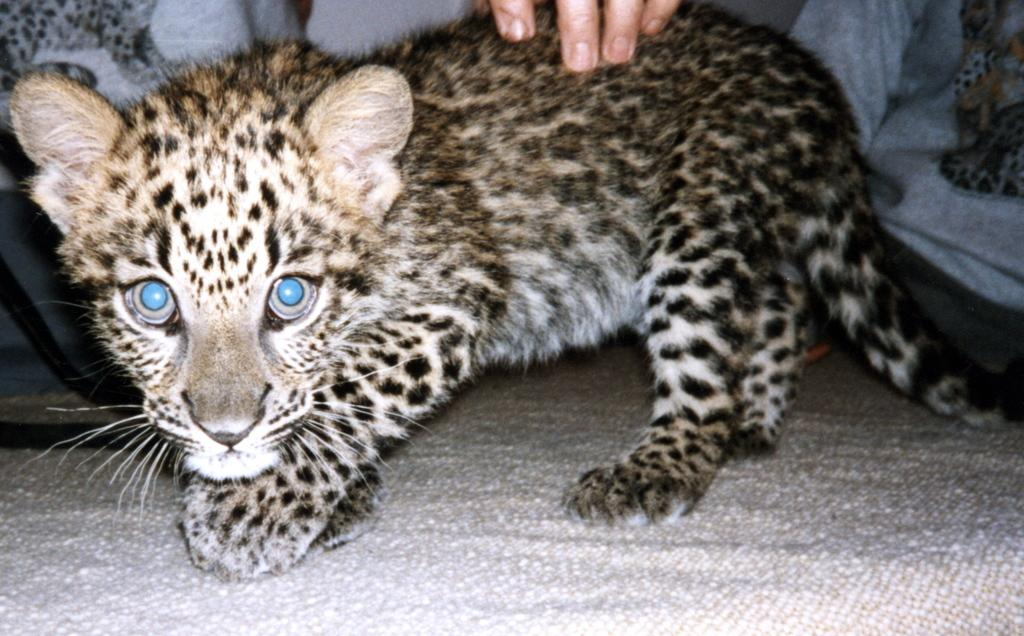What part of a person is visible in the image? There is a person's hand in the image. What is the person's hand touching or holding? The person's hand is on a tiger. What type of eggnog is being served by the servant in the image? There is no servant or eggnog present in the image; it only features a person's hand on a tiger. 